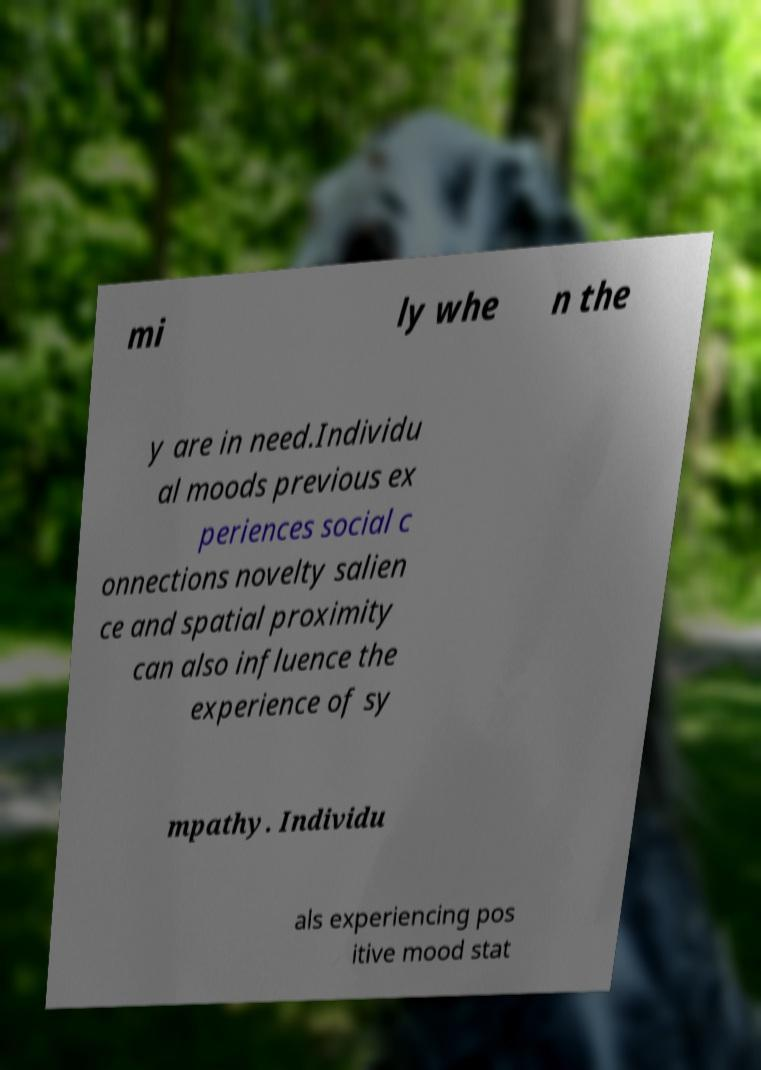Could you extract and type out the text from this image? mi ly whe n the y are in need.Individu al moods previous ex periences social c onnections novelty salien ce and spatial proximity can also influence the experience of sy mpathy. Individu als experiencing pos itive mood stat 